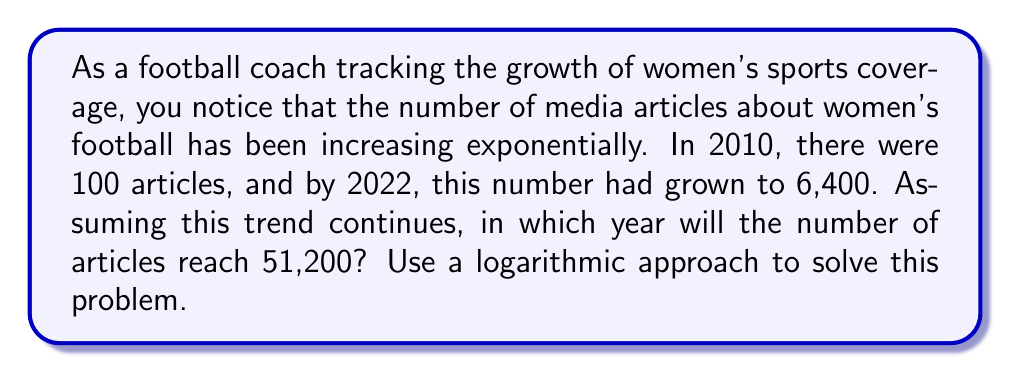Solve this math problem. Let's approach this step-by-step using logarithms:

1) Let's define our variables:
   $y = $ number of years since 2010
   $A = $ number of articles

2) We can model this exponential growth as:
   $A = 100 * 2^x$, where $x$ is the number of doublings

3) We know two points on this curve:
   (2010, 100) and (2022, 6400)

4) Let's find $x$ for 2022:
   $6400 = 100 * 2^x$
   $64 = 2^x$

5) Taking $\log_2$ of both sides:
   $\log_2(64) = x$
   $6 = x$

6) So in 12 years (2010 to 2022), the number of articles doubled 6 times.
   The rate of doubling is $6/12 = 0.5$ times per year.

7) Now, let's find when it will reach 51,200:
   $51200 = 100 * 2^x$
   $512 = 2^x$

8) Taking $\log_2$ of both sides:
   $\log_2(512) = x$
   $9 = x$

9) If it takes 0.5 years for each doubling, and we need 9 doublings:
   $9 / 0.5 = 18$ years after 2010

10) Therefore, this will occur in 2010 + 18 = 2028
Answer: 2028 